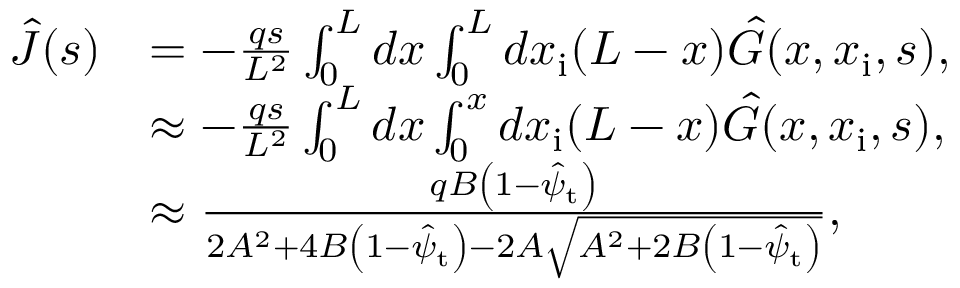Convert formula to latex. <formula><loc_0><loc_0><loc_500><loc_500>\begin{array} { r l } { \hat { J } ( s ) } & { = - \frac { q s } { L ^ { 2 } } \int _ { 0 } ^ { L } d x \int _ { 0 } ^ { L } d x _ { i } ( L - x ) \hat { G } ( x , x _ { i } , s ) , } \\ & { \approx - \frac { q s } { L ^ { 2 } } \int _ { 0 } ^ { L } d x \int _ { 0 } ^ { x } d x _ { i } ( L - x ) \hat { G } ( x , x _ { i } , s ) , } \\ & { \approx \frac { q B \left ( 1 - \hat { \psi } _ { t } \right ) } { 2 A ^ { 2 } + 4 B \left ( 1 - \hat { \psi } _ { t } \right ) - 2 A \sqrt { A ^ { 2 } + 2 B \left ( 1 - \hat { \psi } _ { t } \right ) } } , } \end{array}</formula> 